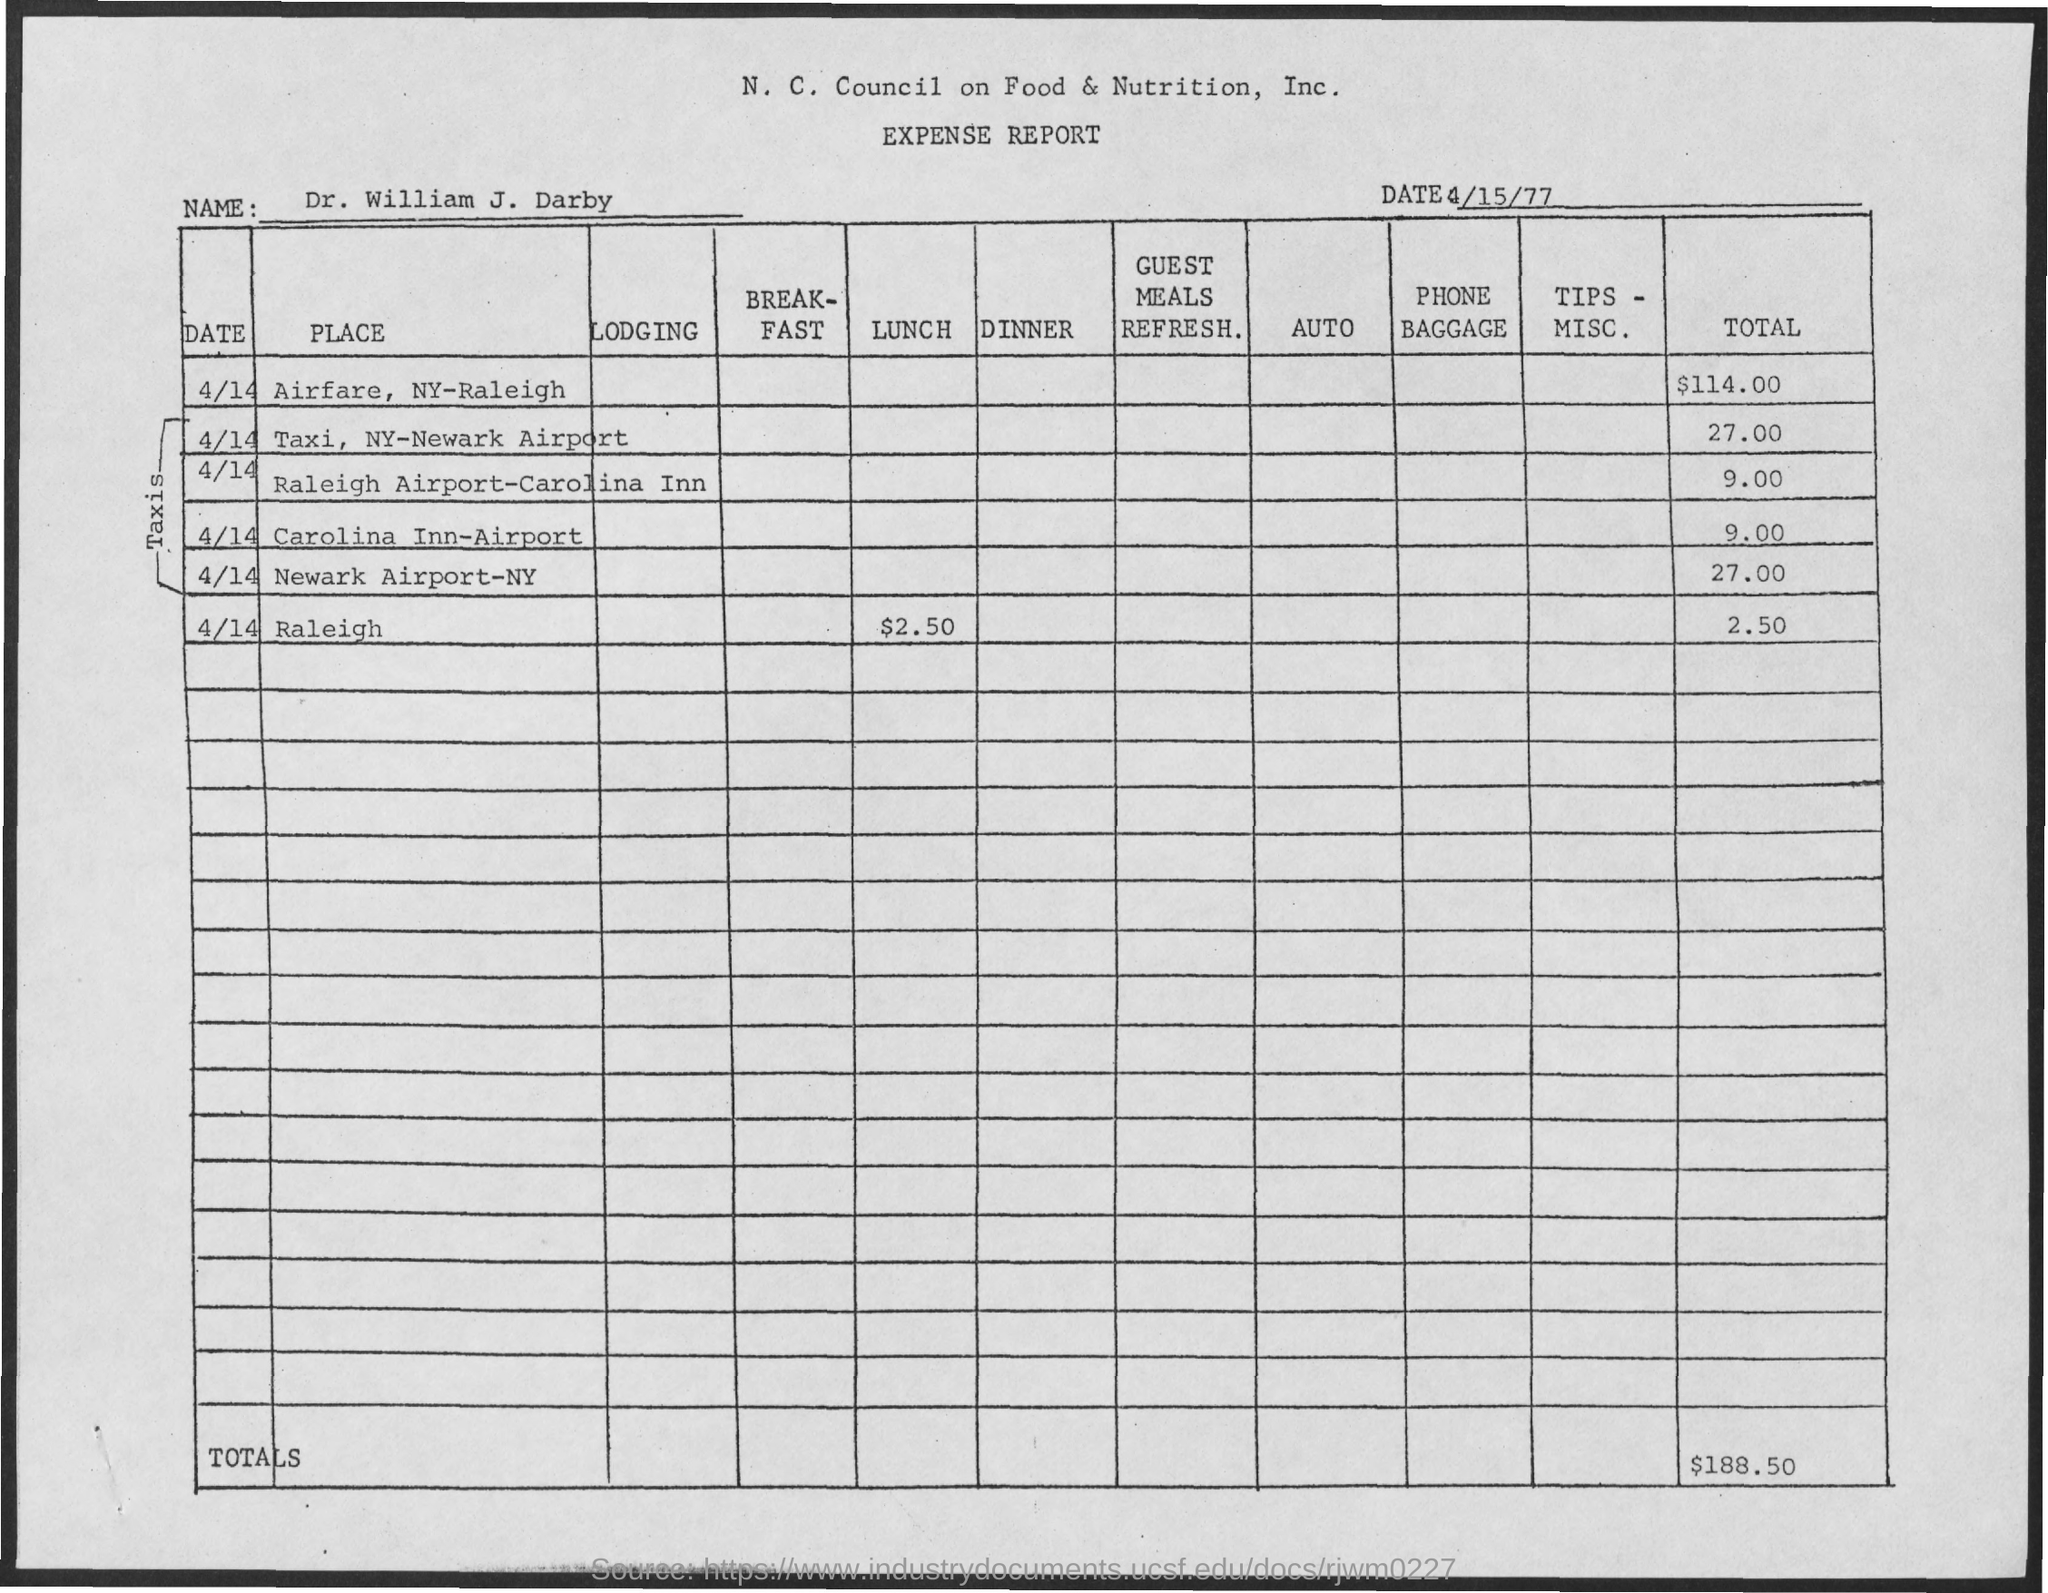What amount is the total expenditure for all items?
Ensure brevity in your answer.  $188.50. What is total expenditure for AirFare?
Your answer should be very brief. $114.00. What is date of this expense report?
Your response must be concise. 4/15/77. 